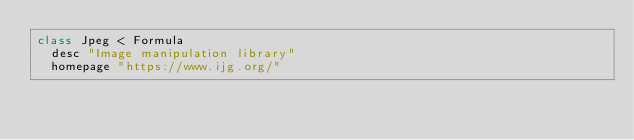Convert code to text. <code><loc_0><loc_0><loc_500><loc_500><_Ruby_>class Jpeg < Formula
  desc "Image manipulation library"
  homepage "https://www.ijg.org/"</code> 